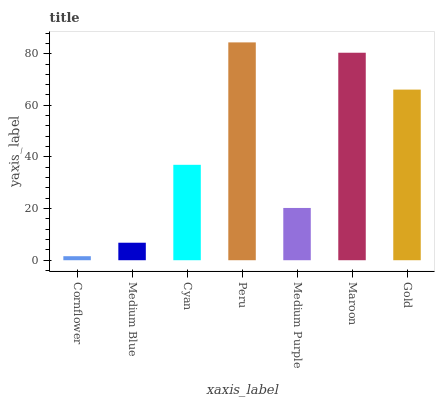Is Cornflower the minimum?
Answer yes or no. Yes. Is Peru the maximum?
Answer yes or no. Yes. Is Medium Blue the minimum?
Answer yes or no. No. Is Medium Blue the maximum?
Answer yes or no. No. Is Medium Blue greater than Cornflower?
Answer yes or no. Yes. Is Cornflower less than Medium Blue?
Answer yes or no. Yes. Is Cornflower greater than Medium Blue?
Answer yes or no. No. Is Medium Blue less than Cornflower?
Answer yes or no. No. Is Cyan the high median?
Answer yes or no. Yes. Is Cyan the low median?
Answer yes or no. Yes. Is Gold the high median?
Answer yes or no. No. Is Gold the low median?
Answer yes or no. No. 